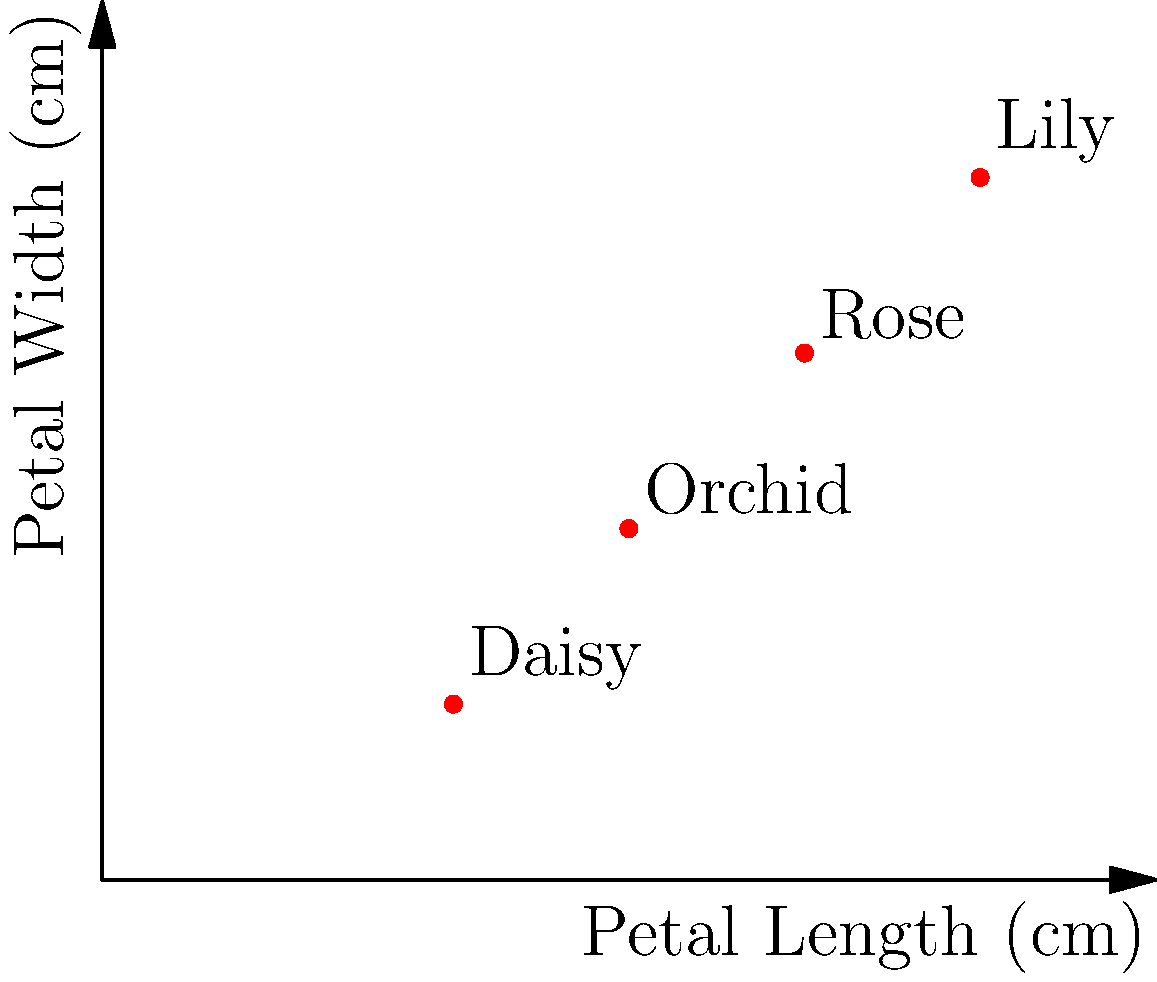In your quest to document rare flowers on Instagram, you've collected data on petal lengths and widths of four unique flowers. The graph shows these measurements as vectors. If we represent the petal lengths as vector $\mathbf{a} = (3, 4, 5, 2)$ and the petal widths as vector $\mathbf{b} = (2, 3, 4, 1)$, what is the dot product $\mathbf{a} \cdot \mathbf{b}$? To find the dot product of vectors $\mathbf{a}$ and $\mathbf{b}$, we multiply corresponding components and sum the results:

1) First, let's identify our vectors:
   $\mathbf{a} = (3, 4, 5, 2)$ (petal lengths)
   $\mathbf{b} = (2, 3, 4, 1)$ (petal widths)

2) The dot product formula is:
   $\mathbf{a} \cdot \mathbf{b} = a_1b_1 + a_2b_2 + a_3b_3 + a_4b_4$

3) Let's multiply corresponding components:
   $(3 \times 2) + (4 \times 3) + (5 \times 4) + (2 \times 1)$

4) Now, let's calculate:
   $6 + 12 + 20 + 2$

5) Sum these values:
   $6 + 12 + 20 + 2 = 40$

Therefore, the dot product $\mathbf{a} \cdot \mathbf{b} = 40$.
Answer: $40$ 